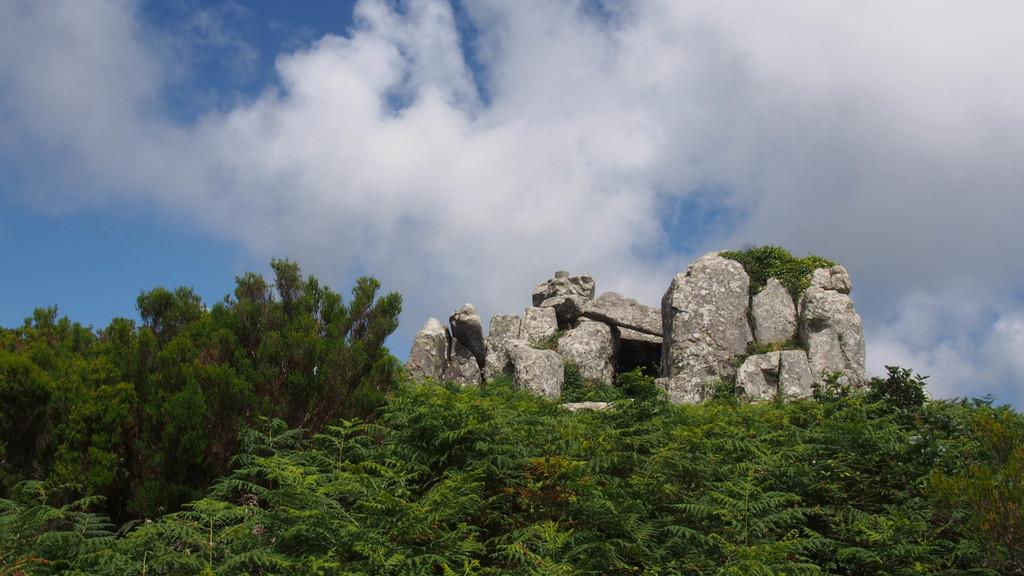What type of vegetation is present in the image? There are green trees in the image. What else can be seen on the ground in the image? There are stones in the image. What is visible in the background of the image? The sky is visible in the background of the image. What can be observed in the sky? Clouds are present in the sky. What type of book is resting on the green trees in the image? There is no book present in the image; it only features green trees, stones, and the sky with clouds. 